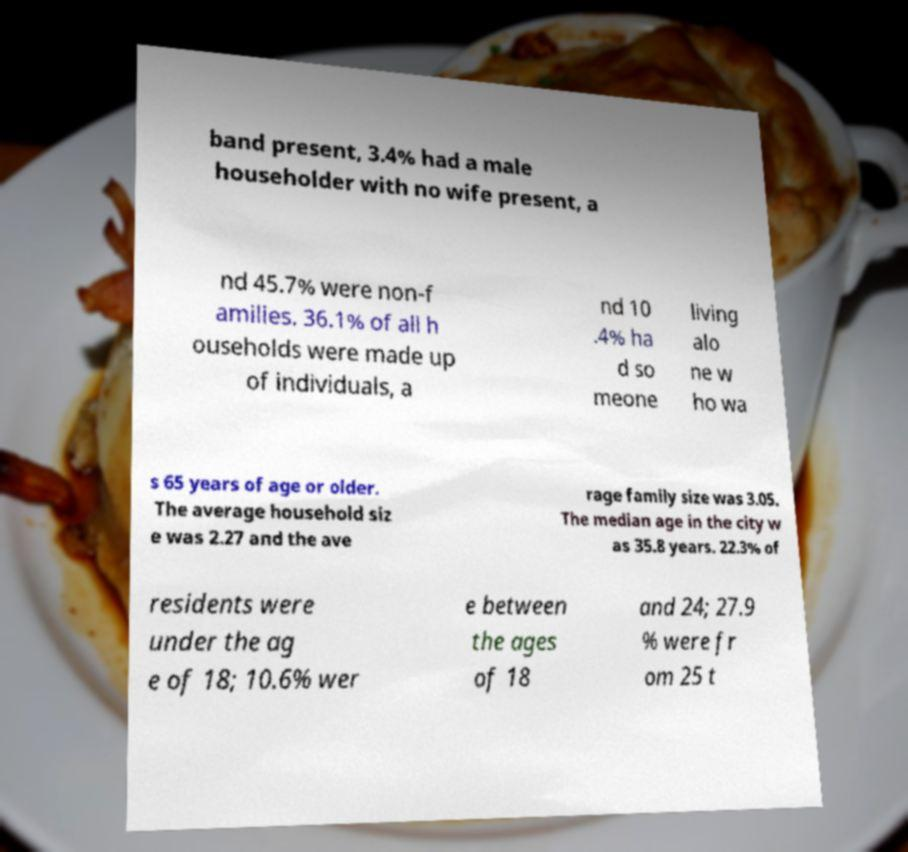Please read and relay the text visible in this image. What does it say? band present, 3.4% had a male householder with no wife present, a nd 45.7% were non-f amilies. 36.1% of all h ouseholds were made up of individuals, a nd 10 .4% ha d so meone living alo ne w ho wa s 65 years of age or older. The average household siz e was 2.27 and the ave rage family size was 3.05. The median age in the city w as 35.8 years. 22.3% of residents were under the ag e of 18; 10.6% wer e between the ages of 18 and 24; 27.9 % were fr om 25 t 